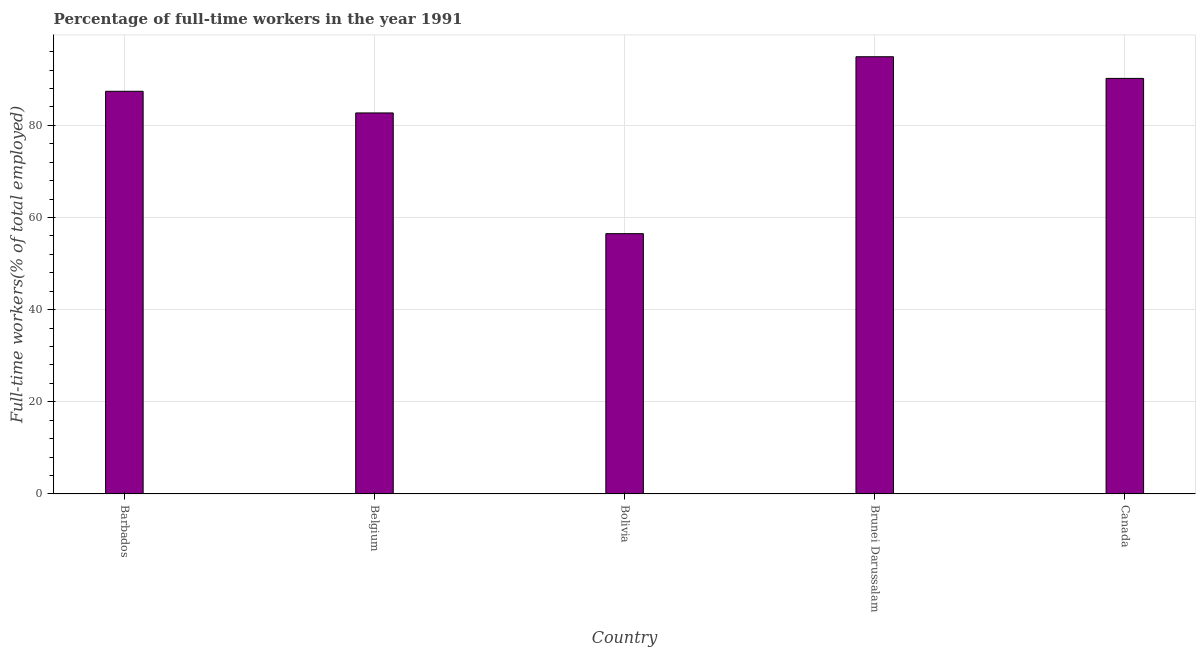What is the title of the graph?
Your answer should be very brief. Percentage of full-time workers in the year 1991. What is the label or title of the Y-axis?
Give a very brief answer. Full-time workers(% of total employed). What is the percentage of full-time workers in Canada?
Offer a terse response. 90.2. Across all countries, what is the maximum percentage of full-time workers?
Your response must be concise. 94.9. Across all countries, what is the minimum percentage of full-time workers?
Ensure brevity in your answer.  56.5. In which country was the percentage of full-time workers maximum?
Offer a very short reply. Brunei Darussalam. In which country was the percentage of full-time workers minimum?
Provide a succinct answer. Bolivia. What is the sum of the percentage of full-time workers?
Ensure brevity in your answer.  411.7. What is the difference between the percentage of full-time workers in Barbados and Belgium?
Your answer should be very brief. 4.7. What is the average percentage of full-time workers per country?
Offer a very short reply. 82.34. What is the median percentage of full-time workers?
Provide a short and direct response. 87.4. What is the ratio of the percentage of full-time workers in Belgium to that in Bolivia?
Keep it short and to the point. 1.46. Is the difference between the percentage of full-time workers in Belgium and Canada greater than the difference between any two countries?
Offer a terse response. No. Is the sum of the percentage of full-time workers in Brunei Darussalam and Canada greater than the maximum percentage of full-time workers across all countries?
Your response must be concise. Yes. What is the difference between the highest and the lowest percentage of full-time workers?
Your response must be concise. 38.4. Are all the bars in the graph horizontal?
Provide a succinct answer. No. How many countries are there in the graph?
Ensure brevity in your answer.  5. What is the difference between two consecutive major ticks on the Y-axis?
Provide a short and direct response. 20. What is the Full-time workers(% of total employed) in Barbados?
Give a very brief answer. 87.4. What is the Full-time workers(% of total employed) of Belgium?
Provide a succinct answer. 82.7. What is the Full-time workers(% of total employed) of Bolivia?
Make the answer very short. 56.5. What is the Full-time workers(% of total employed) in Brunei Darussalam?
Ensure brevity in your answer.  94.9. What is the Full-time workers(% of total employed) in Canada?
Ensure brevity in your answer.  90.2. What is the difference between the Full-time workers(% of total employed) in Barbados and Belgium?
Your answer should be compact. 4.7. What is the difference between the Full-time workers(% of total employed) in Barbados and Bolivia?
Offer a terse response. 30.9. What is the difference between the Full-time workers(% of total employed) in Belgium and Bolivia?
Make the answer very short. 26.2. What is the difference between the Full-time workers(% of total employed) in Belgium and Brunei Darussalam?
Offer a very short reply. -12.2. What is the difference between the Full-time workers(% of total employed) in Bolivia and Brunei Darussalam?
Ensure brevity in your answer.  -38.4. What is the difference between the Full-time workers(% of total employed) in Bolivia and Canada?
Offer a very short reply. -33.7. What is the difference between the Full-time workers(% of total employed) in Brunei Darussalam and Canada?
Provide a succinct answer. 4.7. What is the ratio of the Full-time workers(% of total employed) in Barbados to that in Belgium?
Offer a terse response. 1.06. What is the ratio of the Full-time workers(% of total employed) in Barbados to that in Bolivia?
Your answer should be compact. 1.55. What is the ratio of the Full-time workers(% of total employed) in Barbados to that in Brunei Darussalam?
Your answer should be very brief. 0.92. What is the ratio of the Full-time workers(% of total employed) in Belgium to that in Bolivia?
Your answer should be compact. 1.46. What is the ratio of the Full-time workers(% of total employed) in Belgium to that in Brunei Darussalam?
Provide a succinct answer. 0.87. What is the ratio of the Full-time workers(% of total employed) in Belgium to that in Canada?
Keep it short and to the point. 0.92. What is the ratio of the Full-time workers(% of total employed) in Bolivia to that in Brunei Darussalam?
Offer a very short reply. 0.59. What is the ratio of the Full-time workers(% of total employed) in Bolivia to that in Canada?
Keep it short and to the point. 0.63. What is the ratio of the Full-time workers(% of total employed) in Brunei Darussalam to that in Canada?
Your response must be concise. 1.05. 